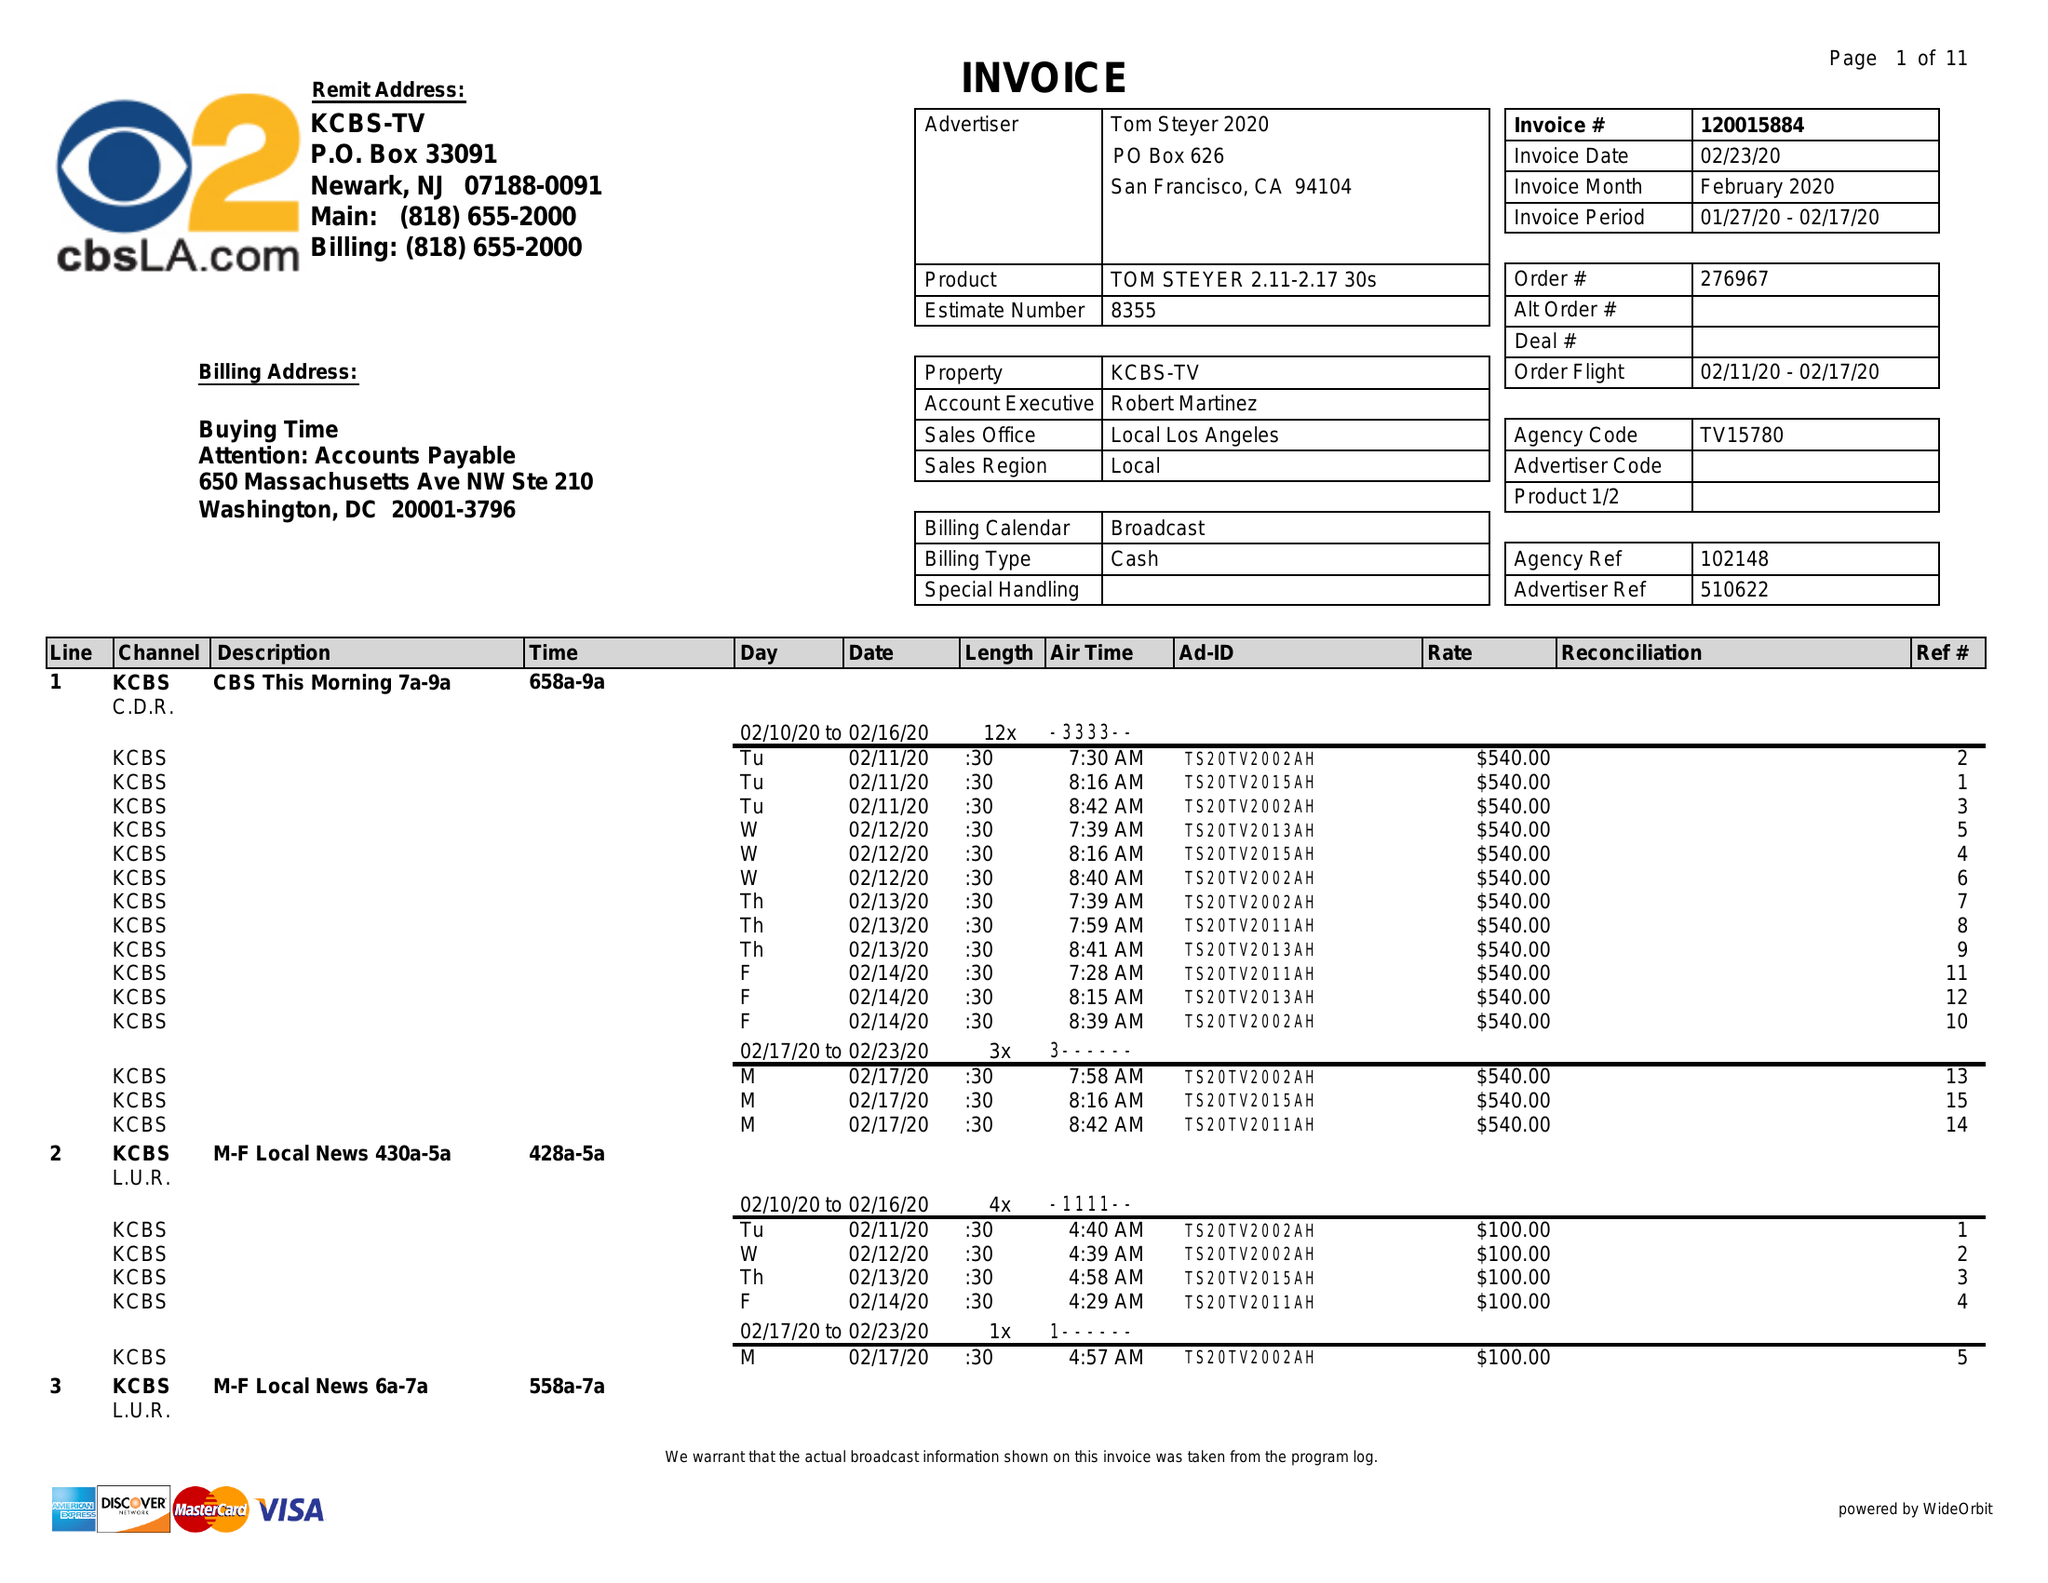What is the value for the flight_to?
Answer the question using a single word or phrase. 02/17/20 